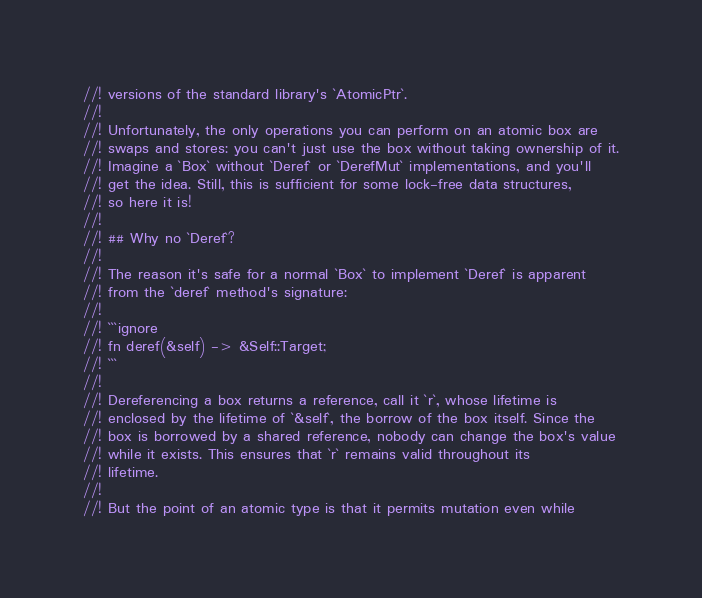<code> <loc_0><loc_0><loc_500><loc_500><_Rust_>//! versions of the standard library's `AtomicPtr`.
//!
//! Unfortunately, the only operations you can perform on an atomic box are
//! swaps and stores: you can't just use the box without taking ownership of it.
//! Imagine a `Box` without `Deref` or `DerefMut` implementations, and you'll
//! get the idea. Still, this is sufficient for some lock-free data structures,
//! so here it is!
//!
//! ## Why no `Deref`?
//!
//! The reason it's safe for a normal `Box` to implement `Deref` is apparent
//! from the `deref` method's signature:
//!
//! ```ignore
//! fn deref(&self) -> &Self::Target;
//! ```
//!
//! Dereferencing a box returns a reference, call it `r`, whose lifetime is
//! enclosed by the lifetime of `&self`, the borrow of the box itself. Since the
//! box is borrowed by a shared reference, nobody can change the box's value
//! while it exists. This ensures that `r` remains valid throughout its
//! lifetime.
//!
//! But the point of an atomic type is that it permits mutation even while</code> 